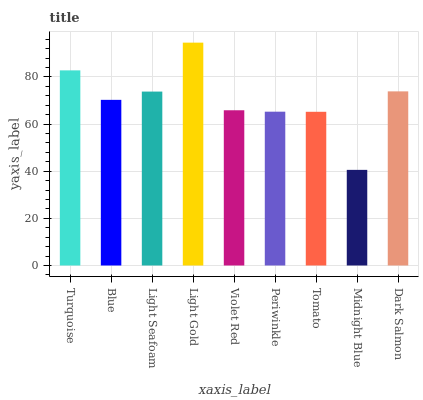Is Midnight Blue the minimum?
Answer yes or no. Yes. Is Light Gold the maximum?
Answer yes or no. Yes. Is Blue the minimum?
Answer yes or no. No. Is Blue the maximum?
Answer yes or no. No. Is Turquoise greater than Blue?
Answer yes or no. Yes. Is Blue less than Turquoise?
Answer yes or no. Yes. Is Blue greater than Turquoise?
Answer yes or no. No. Is Turquoise less than Blue?
Answer yes or no. No. Is Blue the high median?
Answer yes or no. Yes. Is Blue the low median?
Answer yes or no. Yes. Is Light Seafoam the high median?
Answer yes or no. No. Is Light Gold the low median?
Answer yes or no. No. 